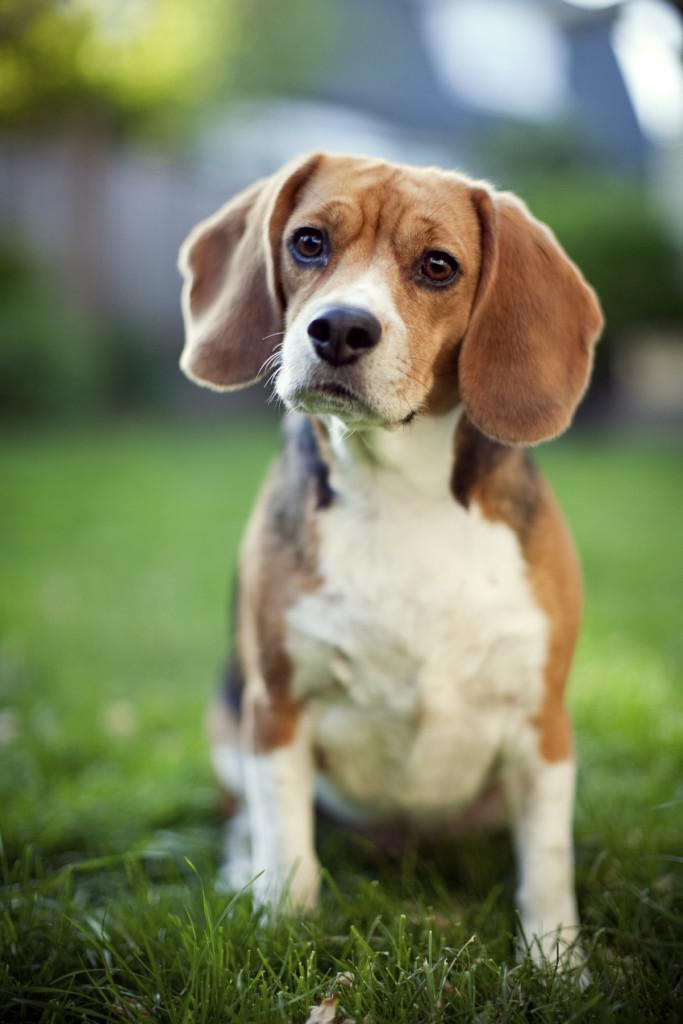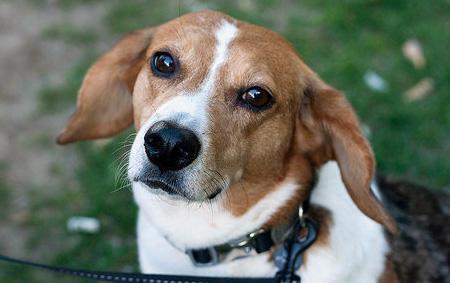The first image is the image on the left, the second image is the image on the right. For the images displayed, is the sentence "In the right image, the beagle wears a leash." factually correct? Answer yes or no. Yes. The first image is the image on the left, the second image is the image on the right. Evaluate the accuracy of this statement regarding the images: "An image shows a sitting beagle eyeing the camera, with a tag dangling from its collar.". Is it true? Answer yes or no. No. 